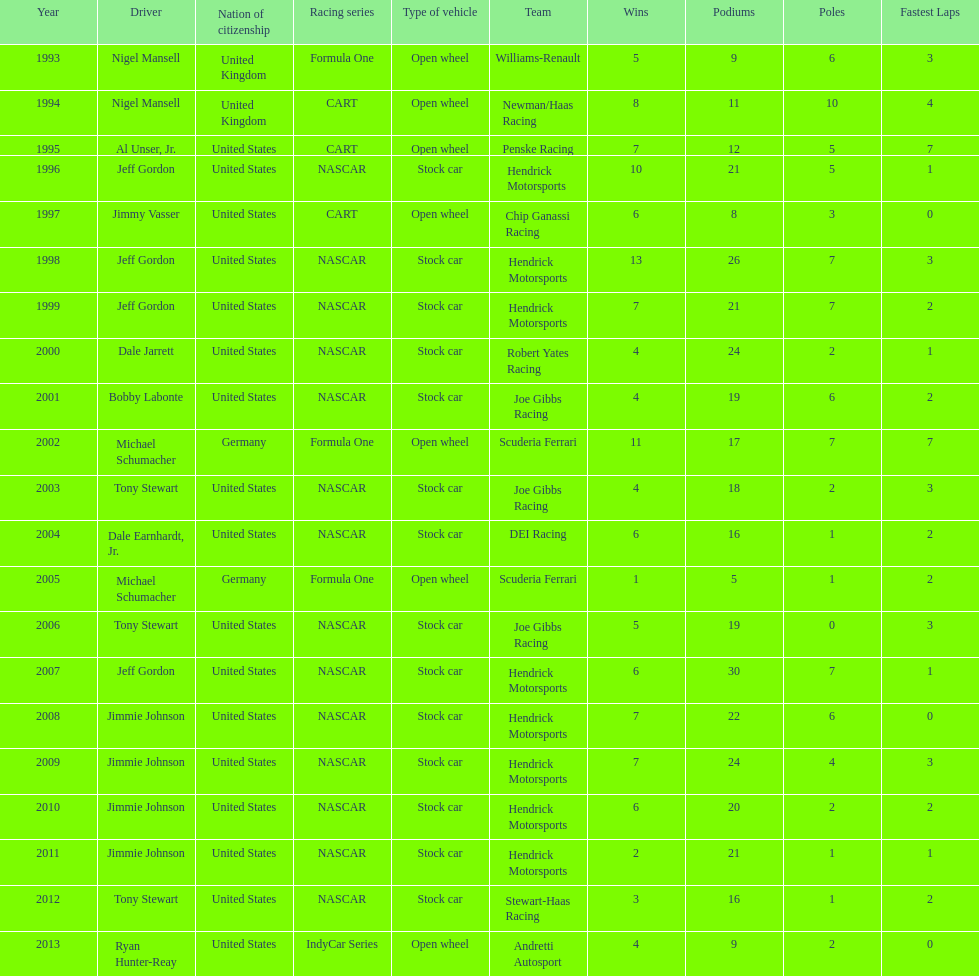Which racing series has the highest total of winners? NASCAR. 